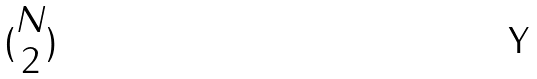Convert formula to latex. <formula><loc_0><loc_0><loc_500><loc_500>( \begin{matrix} N \\ 2 \end{matrix} )</formula> 